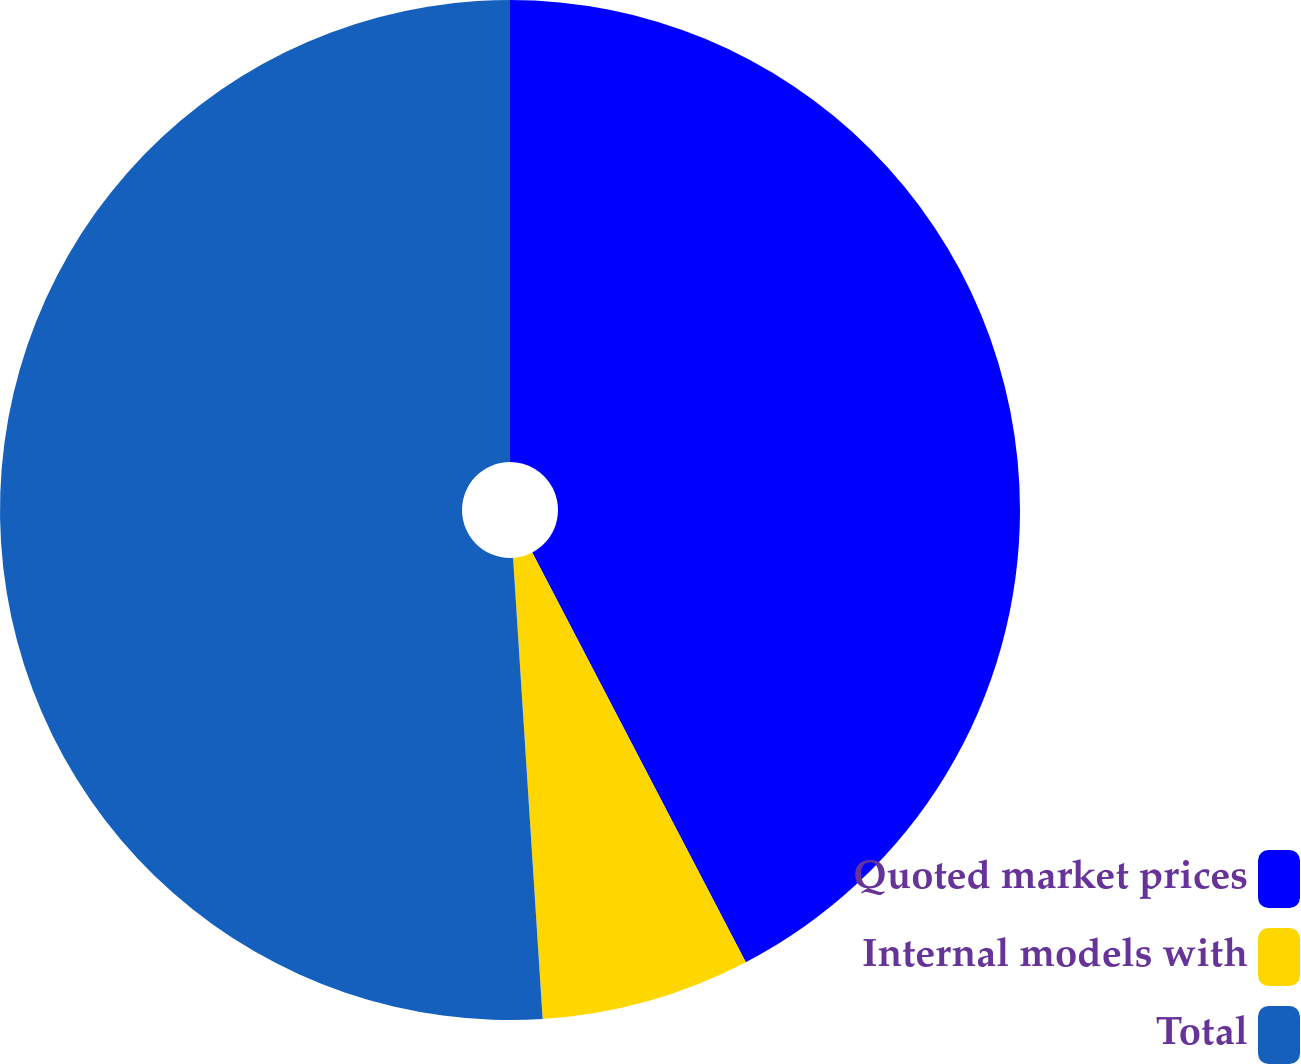Convert chart. <chart><loc_0><loc_0><loc_500><loc_500><pie_chart><fcel>Quoted market prices<fcel>Internal models with<fcel>Total<nl><fcel>42.35%<fcel>6.63%<fcel>51.02%<nl></chart> 